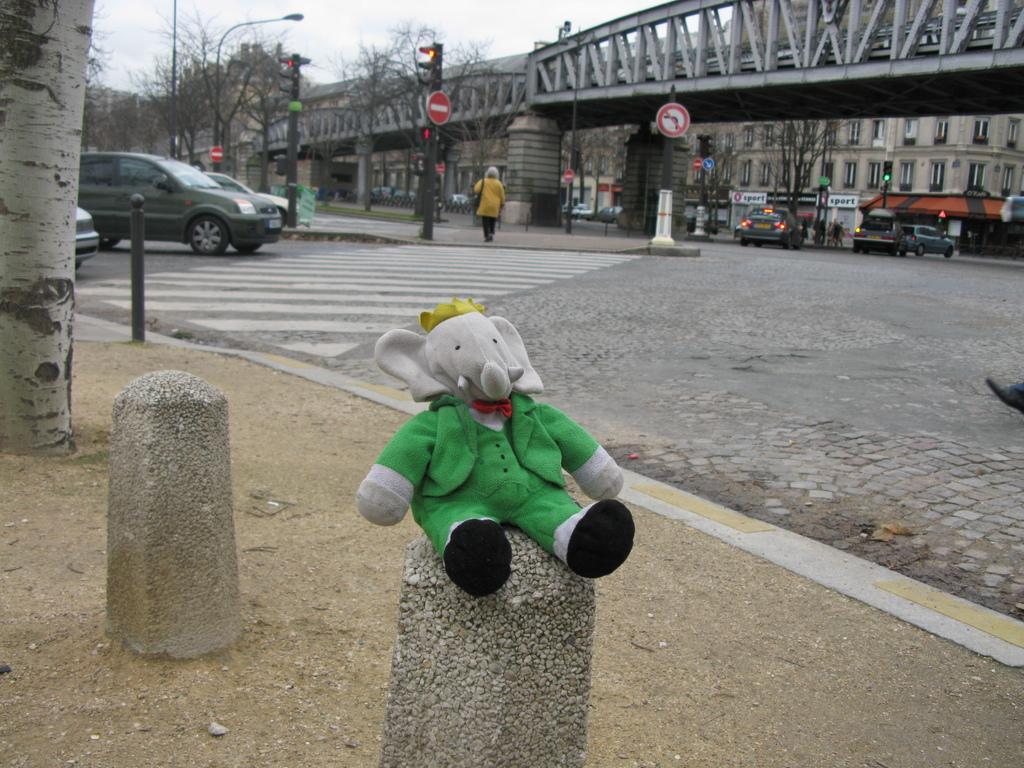In one or two sentences, can you explain what this image depicts? In this image I can see a grey colour soft toy, I can see this toy is wearing green colour dress. In background I can see a bridge, few sign boards, few poles, few signal lights, number of vehicles on road, white lines on this road and I can also see few people are standing. Over there I can see a building and I can also see number of trees. 